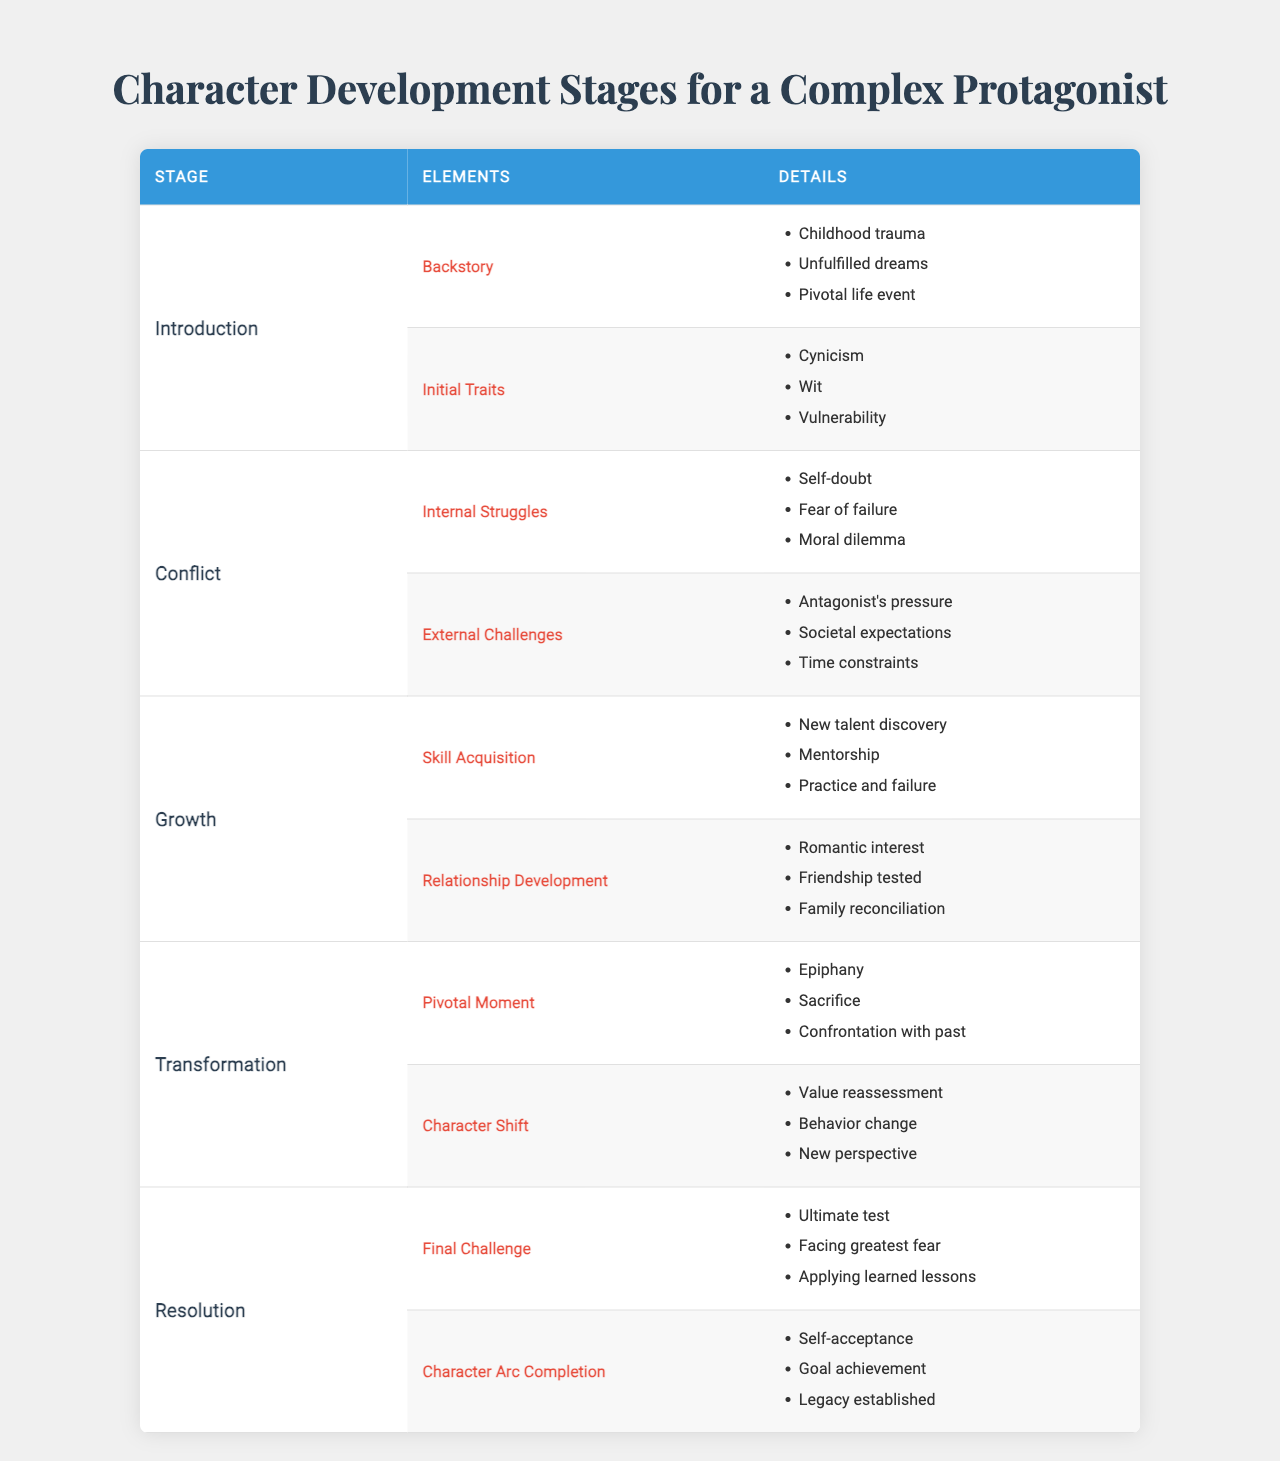What are the initial traits of the protagonist in the introduction stage? The initial traits linked to the introduction stage can be found in the corresponding section under the "Initial Traits" element, which lists: "Cynicism," "Wit," and "Vulnerability."
Answer: Cynicism, Wit, Vulnerability How many elements are there in the conflict stage? By looking at the conflict stage in the table, we see there are two elements listed: "Internal Struggles" and "External Challenges."
Answer: 2 Is "Fear of failure" part of the internal struggles? The internal struggles section in the conflict stage specifies "Fear of failure" as one of the details, confirming that it is indeed part of it.
Answer: Yes Which pivotal moment details are in the transformation stage? The transformation stage features a section on "Pivotal Moment," which includes three details: "Epiphany," "Sacrifice," and "Confrontation with past."
Answer: Epiphany, Sacrifice, Confrontation with past How many total details are provided for the elements in the growth stage? The growth stage has two elements, each with three details: "Skill Acquisition" (3) and "Relationship Development" (3). Therefore, the total number of details is 3 + 3 = 6.
Answer: 6 What change occurs to the character's perspective in the transformation stage? The transformation stage mentions a "Character Shift," which includes "New perspective" as one of its details, indicating a change in the character's viewpoint.
Answer: New perspective Which element of the growth stage addresses interpersonal relationships? In the growth stage, the element that addresses interpersonal relationships is "Relationship Development," which lists details such as "Romantic interest," "Friendship tested," and "Family reconciliation."
Answer: Relationship Development Compare the number of details in the introduction stage vs the resolution stage. The introduction stage has five details (three under Backstory and two under Initial Traits), while the resolution stage has six details (three under Final Challenge and three under Character Arc Completion). Thus, the resolution stage has one more detail than the introduction stage.
Answer: Resolution stage has 1 more detail What major theme do all stages contribute to regarding the character's journey? All stages contribute to the major theme of personal evolution and overcoming challenges as the character develops from their introduction to resolution, highlighting internal and external conflicts, growth opportunities, and transformative moments.
Answer: Personal evolution and overcoming challenges 